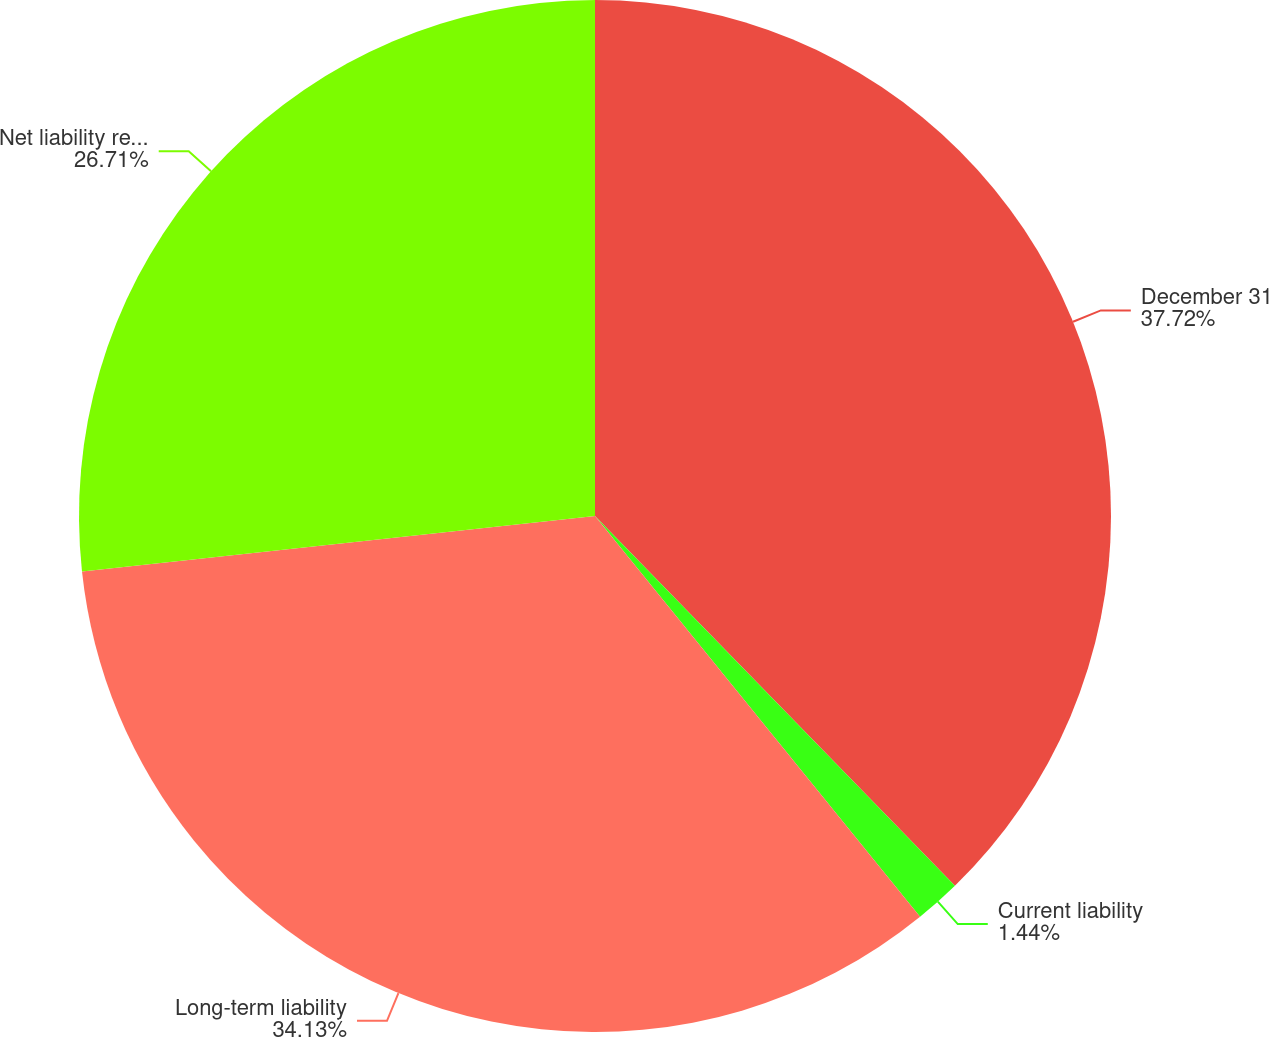<chart> <loc_0><loc_0><loc_500><loc_500><pie_chart><fcel>December 31<fcel>Current liability<fcel>Long-term liability<fcel>Net liability recognized<nl><fcel>37.71%<fcel>1.44%<fcel>34.13%<fcel>26.71%<nl></chart> 